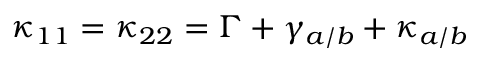<formula> <loc_0><loc_0><loc_500><loc_500>\kappa _ { 1 1 } = \kappa _ { 2 2 } = \Gamma + \gamma _ { a / b } + \kappa _ { a / b }</formula> 